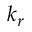<formula> <loc_0><loc_0><loc_500><loc_500>k _ { r }</formula> 